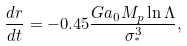Convert formula to latex. <formula><loc_0><loc_0><loc_500><loc_500>\frac { d r } { d t } = - 0 . 4 5 \frac { G a _ { 0 } M _ { p } \ln \Lambda } { \sigma _ { ^ { * } } ^ { 3 } } ,</formula> 